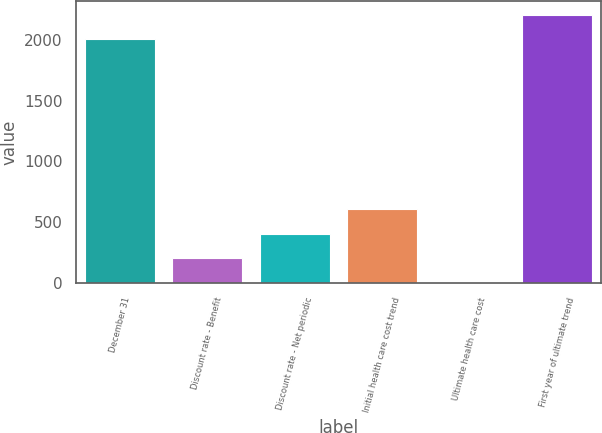Convert chart. <chart><loc_0><loc_0><loc_500><loc_500><bar_chart><fcel>December 31<fcel>Discount rate - Benefit<fcel>Discount rate - Net periodic<fcel>Initial health care cost trend<fcel>Ultimate health care cost<fcel>First year of ultimate trend<nl><fcel>2004<fcel>205.9<fcel>406.8<fcel>607.7<fcel>5<fcel>2204.9<nl></chart> 